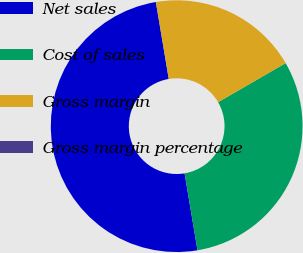<chart> <loc_0><loc_0><loc_500><loc_500><pie_chart><fcel>Net sales<fcel>Cost of sales<fcel>Gross margin<fcel>Gross margin percentage<nl><fcel>49.99%<fcel>30.7%<fcel>19.29%<fcel>0.01%<nl></chart> 